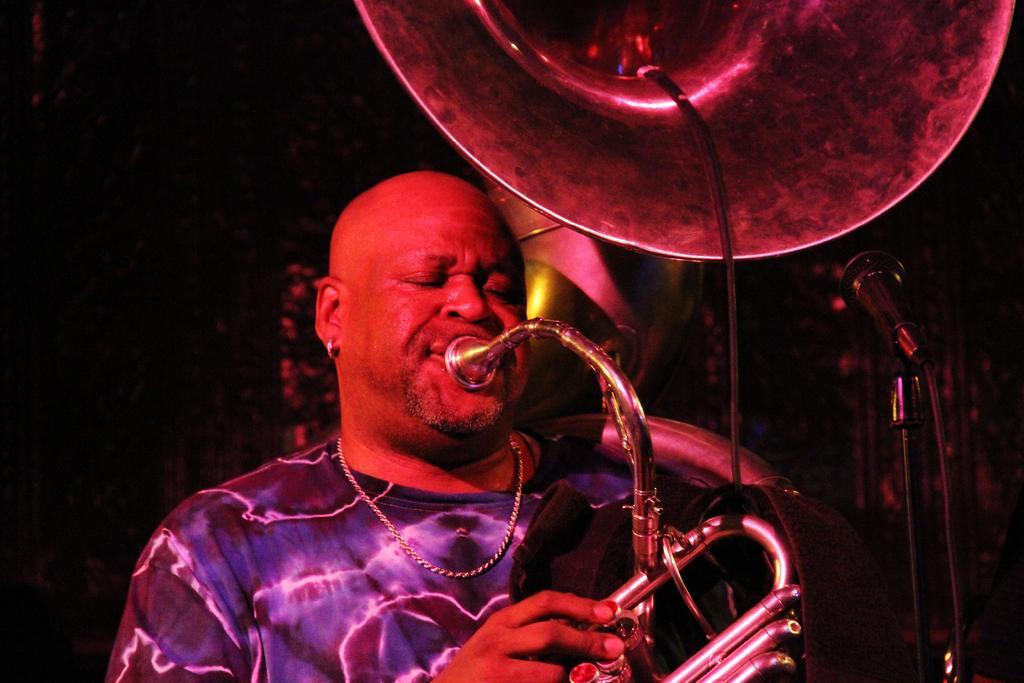How would you summarize this image in a sentence or two? In this picture one man is standing in blue and black t-shirt and he is holding a big musical instrument and playing it in front of the microphone and behind him there is black background. 